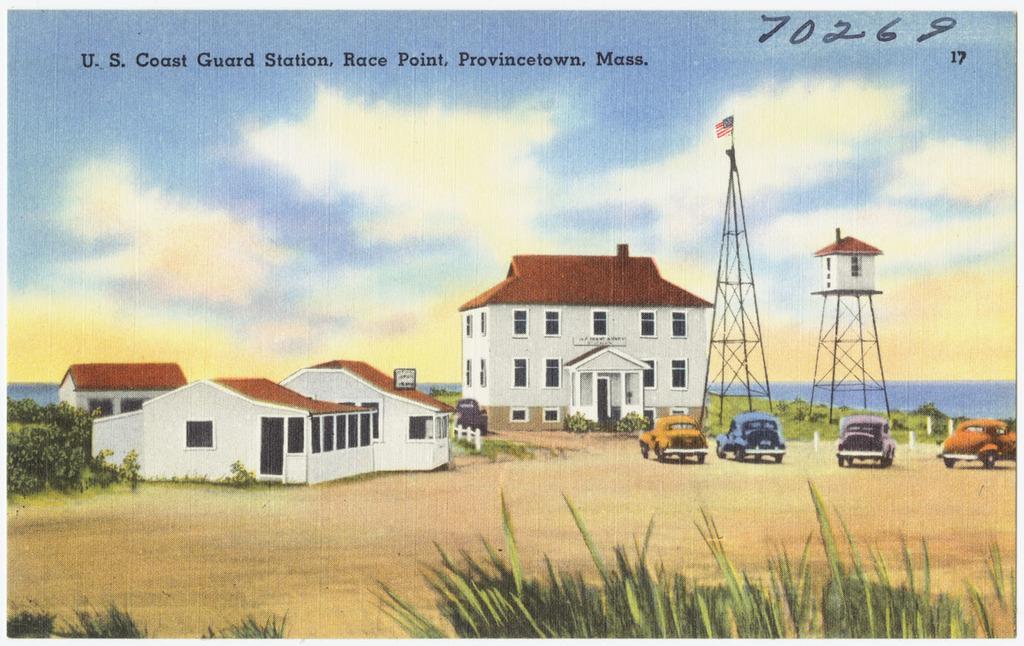Describe this image in one or two sentences. In the middle of the image I can see houses. On the left side of the image I can see trees. On the right side of the image I can see the cars. At the top of the image I can see some written text. 